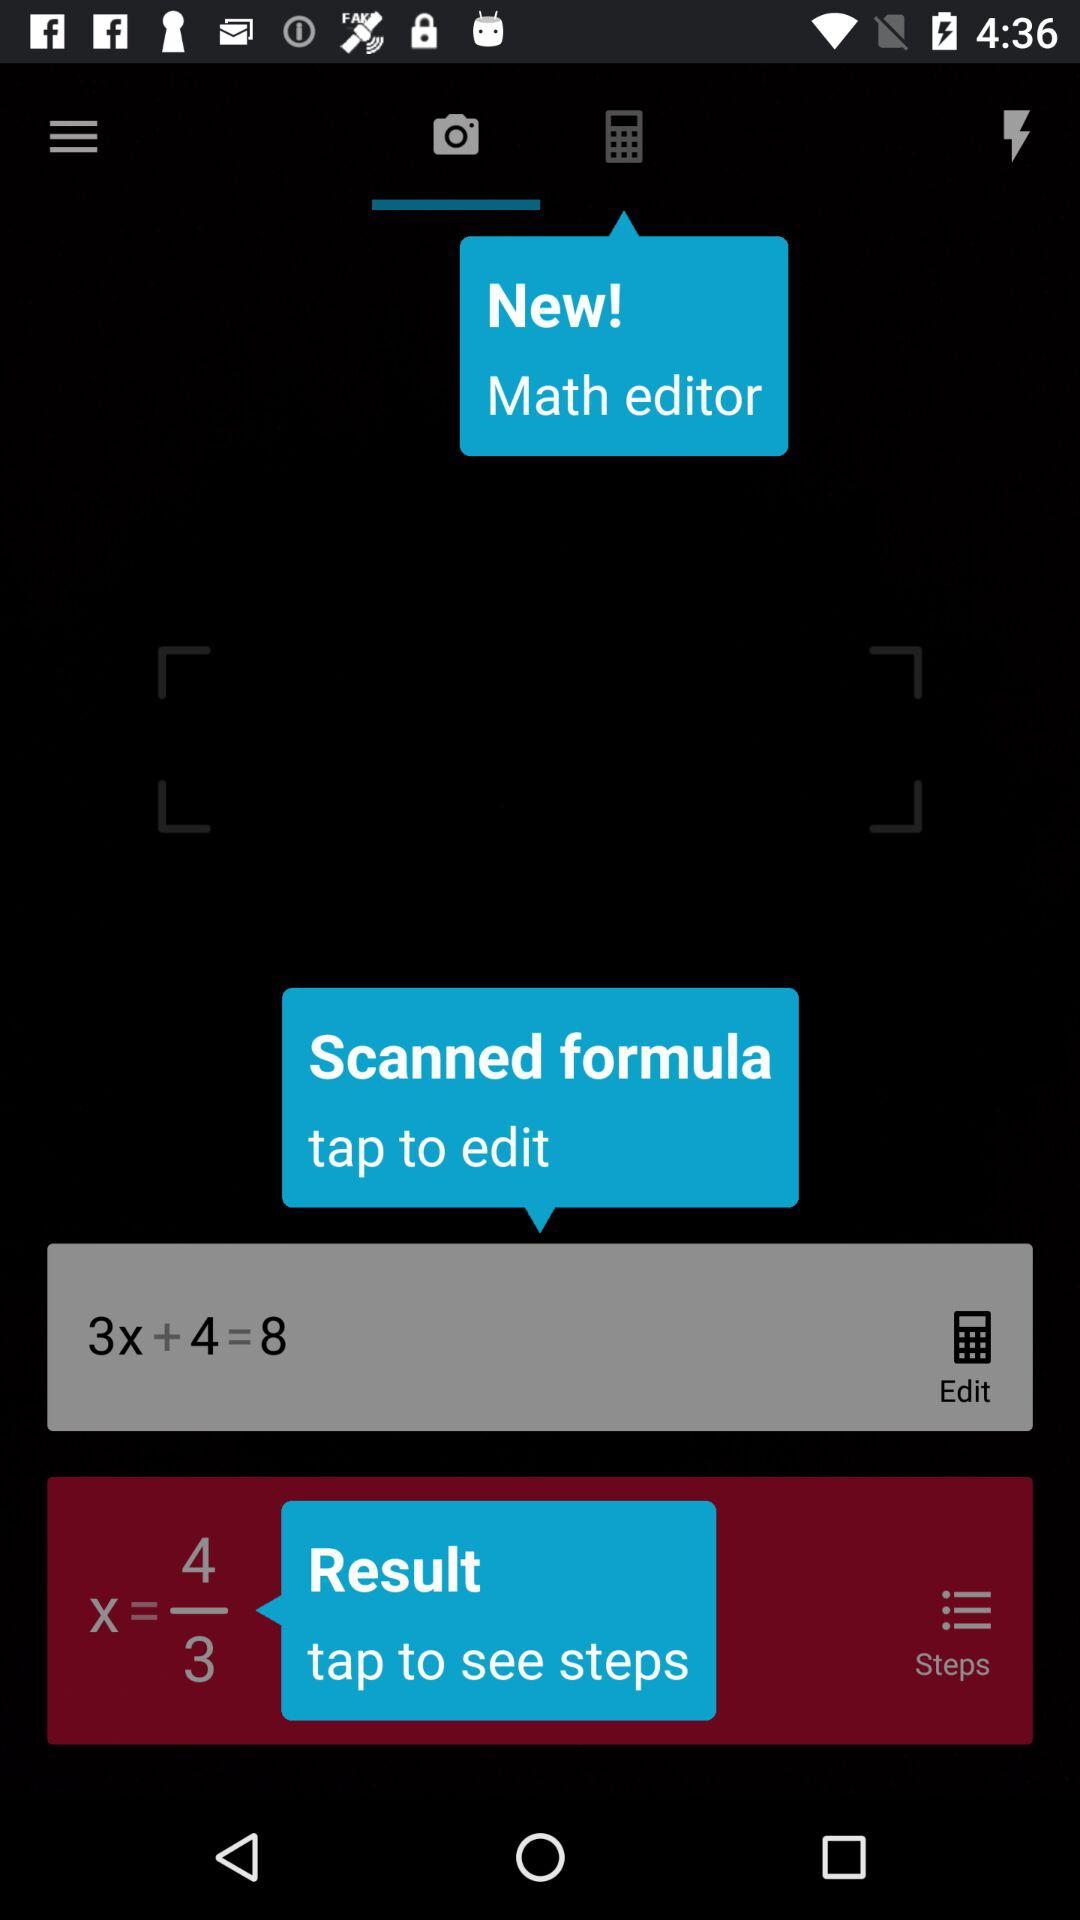What is the scanned formula? The scanned formula is 3x + 4 = 8. 